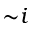<formula> <loc_0><loc_0><loc_500><loc_500>{ \sim } i</formula> 